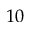<formula> <loc_0><loc_0><loc_500><loc_500>1 0</formula> 